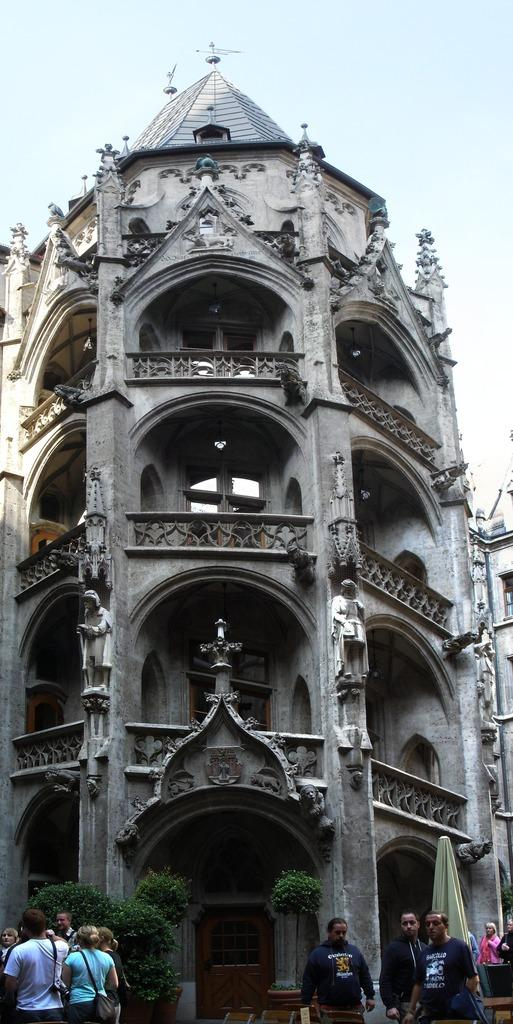What is the main structure in the image? There is a huge building in the image. What can be seen outside the building? There are plants and trees outside the building. Are there any people present in the image? Yes, there are people standing outside the building. How would you describe the weather based on the image? The sky is clear in the image, suggesting good weather. Where is the dock located in the image? There is no dock present in the image. What type of industry is depicted in the image? The image does not show any industry; it features a huge building, plants, trees, and people. 